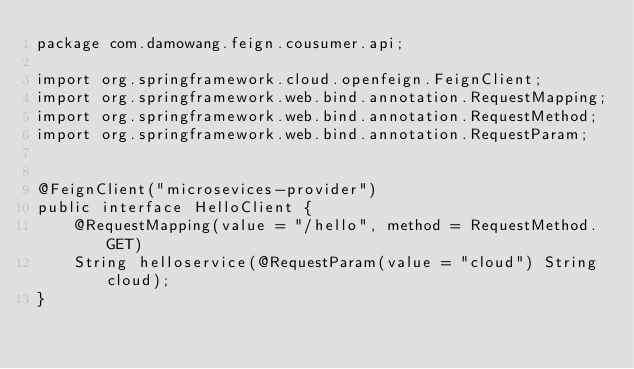Convert code to text. <code><loc_0><loc_0><loc_500><loc_500><_Java_>package com.damowang.feign.cousumer.api;

import org.springframework.cloud.openfeign.FeignClient;
import org.springframework.web.bind.annotation.RequestMapping;
import org.springframework.web.bind.annotation.RequestMethod;
import org.springframework.web.bind.annotation.RequestParam;


@FeignClient("microsevices-provider")
public interface HelloClient {
    @RequestMapping(value = "/hello", method = RequestMethod.GET)
    String helloservice(@RequestParam(value = "cloud") String cloud);
}

</code> 